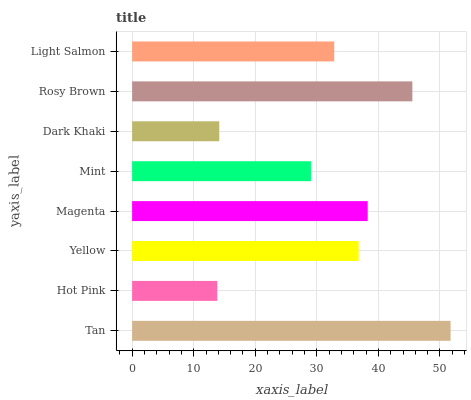Is Hot Pink the minimum?
Answer yes or no. Yes. Is Tan the maximum?
Answer yes or no. Yes. Is Yellow the minimum?
Answer yes or no. No. Is Yellow the maximum?
Answer yes or no. No. Is Yellow greater than Hot Pink?
Answer yes or no. Yes. Is Hot Pink less than Yellow?
Answer yes or no. Yes. Is Hot Pink greater than Yellow?
Answer yes or no. No. Is Yellow less than Hot Pink?
Answer yes or no. No. Is Yellow the high median?
Answer yes or no. Yes. Is Light Salmon the low median?
Answer yes or no. Yes. Is Tan the high median?
Answer yes or no. No. Is Tan the low median?
Answer yes or no. No. 